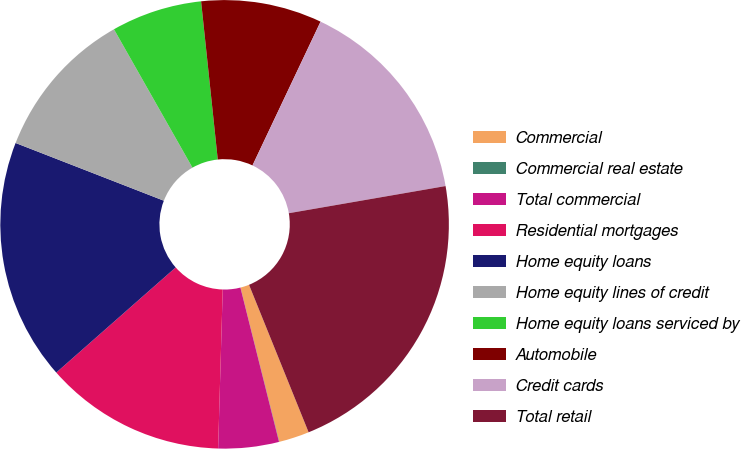<chart> <loc_0><loc_0><loc_500><loc_500><pie_chart><fcel>Commercial<fcel>Commercial real estate<fcel>Total commercial<fcel>Residential mortgages<fcel>Home equity loans<fcel>Home equity lines of credit<fcel>Home equity loans serviced by<fcel>Automobile<fcel>Credit cards<fcel>Total retail<nl><fcel>2.19%<fcel>0.02%<fcel>4.36%<fcel>13.05%<fcel>17.4%<fcel>10.88%<fcel>6.54%<fcel>8.71%<fcel>15.23%<fcel>21.62%<nl></chart> 